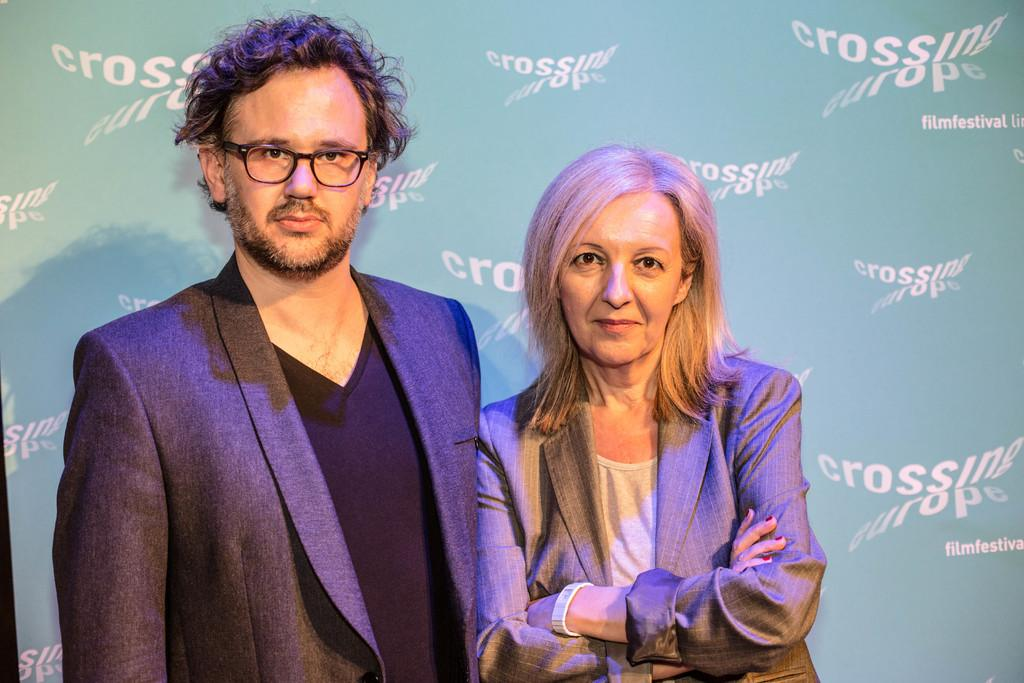What is the appearance of the person on the left side of the image? There is a person in a suit on the left side of the image. What is the person in the suit doing? The person is standing. Can you describe the woman in the image? The woman is smiling and standing. What can be seen on the banner in the background of the image? There are white color texts on a banner in the background of the image. What type of marble is being used to create the fireman's hat in the image? There is no fireman or hat made of marble present in the image. What is the woman's reaction to the surprise in the image? There is no surprise mentioned or depicted in the image. 